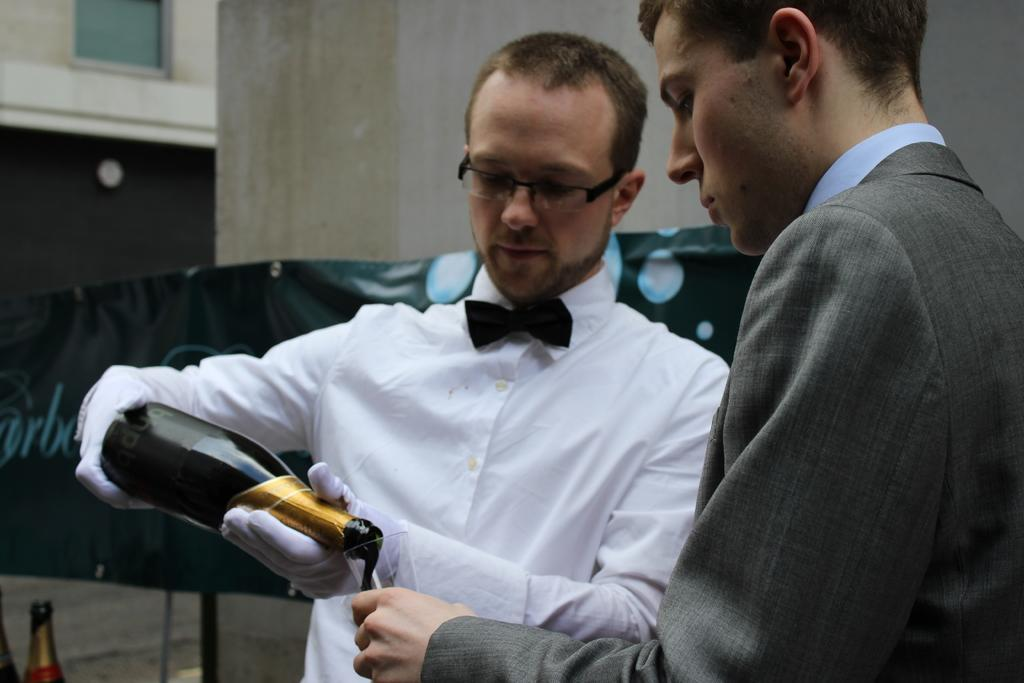How many people are in the image? There are two men in the image. What is one of the men holding? One man is holding a bottle. What is the man with the bottle doing? The man with the bottle is pouring champagne. What is the other man holding? The other man is holding a glass. What is happening with the champagne? The champagne is being poured into the glass. What type of bike is the man with the bottle riding in the image? There is no bike present in the image; the man with the bottle is pouring champagne. What title does the man with the glass hold in the image? There is no title mentioned or implied in the image; the man with the glass is simply holding a glass. 